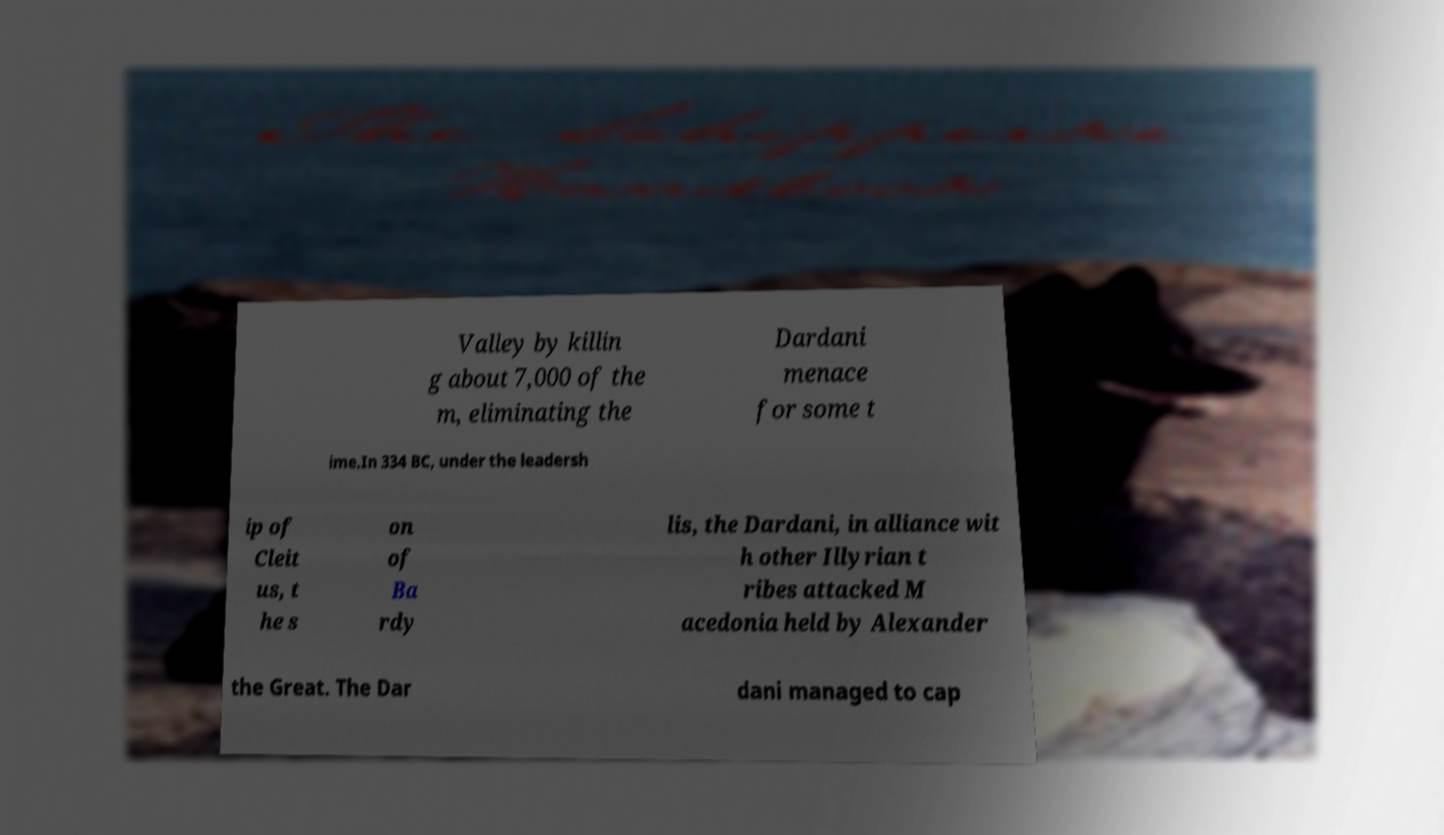Could you extract and type out the text from this image? Valley by killin g about 7,000 of the m, eliminating the Dardani menace for some t ime.In 334 BC, under the leadersh ip of Cleit us, t he s on of Ba rdy lis, the Dardani, in alliance wit h other Illyrian t ribes attacked M acedonia held by Alexander the Great. The Dar dani managed to cap 